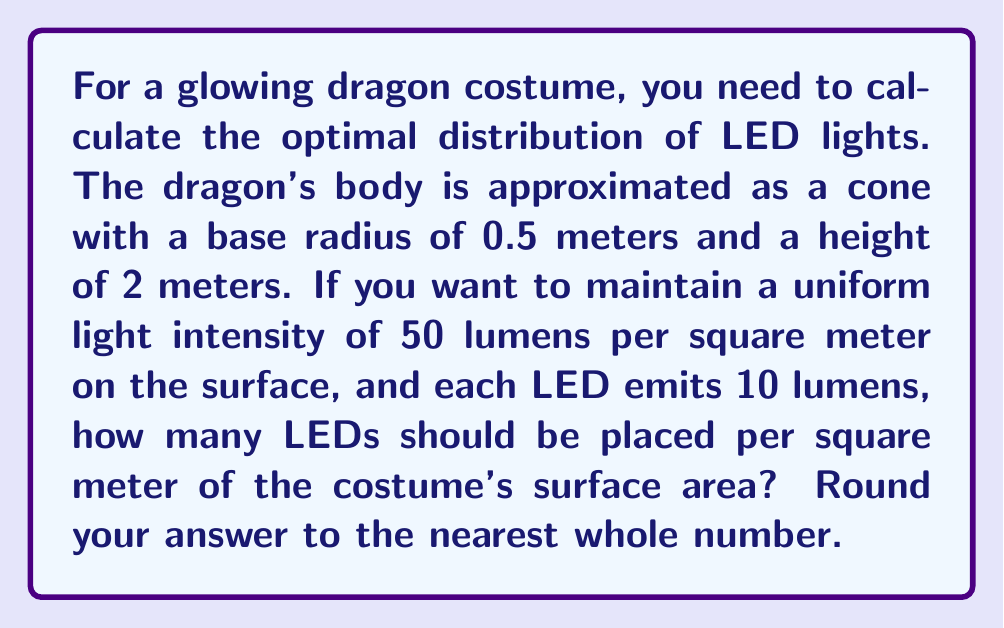Can you solve this math problem? To solve this problem, we'll follow these steps:

1. Calculate the surface area of the conical dragon body:
   The surface area of a cone (excluding the base) is given by:
   $$A = \pi r \sqrt{r^2 + h^2}$$
   where $r$ is the radius of the base and $h$ is the height.

   $$A = \pi \cdot 0.5 \cdot \sqrt{0.5^2 + 2^2}$$
   $$A = 0.5\pi \cdot \sqrt{0.25 + 4}$$
   $$A = 0.5\pi \cdot \sqrt{4.25}$$
   $$A \approx 3.27 \text{ m}^2$$

2. Calculate the total lumens required:
   Given uniform intensity of 50 lumens per square meter:
   $$\text{Total lumens} = 50 \text{ lm/m}^2 \cdot 3.27 \text{ m}^2 = 163.5 \text{ lm}$$

3. Calculate the number of LEDs needed:
   Each LED emits 10 lumens:
   $$\text{Number of LEDs} = \frac{163.5 \text{ lm}}{10 \text{ lm/LED}} = 16.35 \text{ LEDs}$$

4. Calculate LEDs per square meter:
   $$\text{LEDs per m}^2 = \frac{16.35 \text{ LEDs}}{3.27 \text{ m}^2} \approx 5 \text{ LEDs/m}^2$$

Rounding to the nearest whole number, we get 5 LEDs per square meter.
Answer: 5 LEDs/m² 